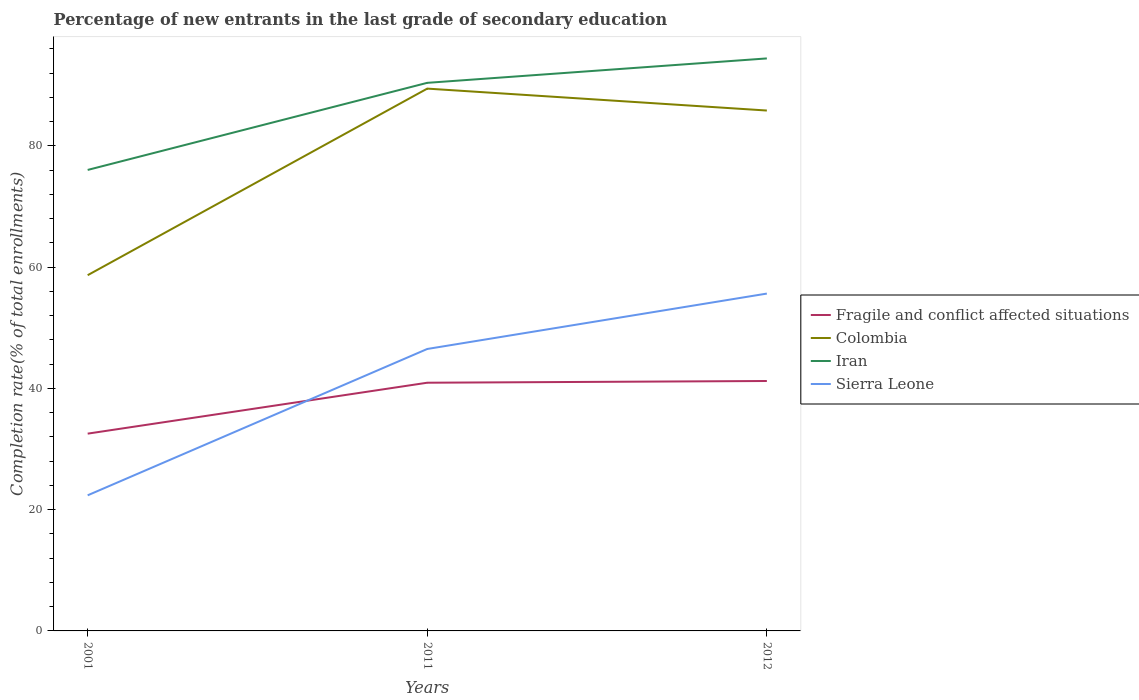Is the number of lines equal to the number of legend labels?
Your answer should be compact. Yes. Across all years, what is the maximum percentage of new entrants in Fragile and conflict affected situations?
Provide a succinct answer. 32.53. What is the total percentage of new entrants in Sierra Leone in the graph?
Provide a succinct answer. -33.27. What is the difference between the highest and the second highest percentage of new entrants in Sierra Leone?
Offer a very short reply. 33.27. What is the difference between the highest and the lowest percentage of new entrants in Colombia?
Keep it short and to the point. 2. Is the percentage of new entrants in Colombia strictly greater than the percentage of new entrants in Fragile and conflict affected situations over the years?
Provide a short and direct response. No. How many lines are there?
Provide a succinct answer. 4. What is the difference between two consecutive major ticks on the Y-axis?
Keep it short and to the point. 20. Are the values on the major ticks of Y-axis written in scientific E-notation?
Provide a succinct answer. No. Where does the legend appear in the graph?
Provide a succinct answer. Center right. What is the title of the graph?
Offer a terse response. Percentage of new entrants in the last grade of secondary education. What is the label or title of the Y-axis?
Provide a short and direct response. Completion rate(% of total enrollments). What is the Completion rate(% of total enrollments) in Fragile and conflict affected situations in 2001?
Keep it short and to the point. 32.53. What is the Completion rate(% of total enrollments) in Colombia in 2001?
Offer a terse response. 58.66. What is the Completion rate(% of total enrollments) in Iran in 2001?
Keep it short and to the point. 76.02. What is the Completion rate(% of total enrollments) of Sierra Leone in 2001?
Give a very brief answer. 22.36. What is the Completion rate(% of total enrollments) in Fragile and conflict affected situations in 2011?
Keep it short and to the point. 40.93. What is the Completion rate(% of total enrollments) in Colombia in 2011?
Offer a terse response. 89.43. What is the Completion rate(% of total enrollments) of Iran in 2011?
Ensure brevity in your answer.  90.38. What is the Completion rate(% of total enrollments) of Sierra Leone in 2011?
Your answer should be very brief. 46.49. What is the Completion rate(% of total enrollments) of Fragile and conflict affected situations in 2012?
Your response must be concise. 41.21. What is the Completion rate(% of total enrollments) in Colombia in 2012?
Give a very brief answer. 85.81. What is the Completion rate(% of total enrollments) of Iran in 2012?
Keep it short and to the point. 94.4. What is the Completion rate(% of total enrollments) in Sierra Leone in 2012?
Offer a very short reply. 55.63. Across all years, what is the maximum Completion rate(% of total enrollments) in Fragile and conflict affected situations?
Keep it short and to the point. 41.21. Across all years, what is the maximum Completion rate(% of total enrollments) of Colombia?
Provide a succinct answer. 89.43. Across all years, what is the maximum Completion rate(% of total enrollments) in Iran?
Provide a succinct answer. 94.4. Across all years, what is the maximum Completion rate(% of total enrollments) in Sierra Leone?
Make the answer very short. 55.63. Across all years, what is the minimum Completion rate(% of total enrollments) in Fragile and conflict affected situations?
Provide a succinct answer. 32.53. Across all years, what is the minimum Completion rate(% of total enrollments) in Colombia?
Offer a very short reply. 58.66. Across all years, what is the minimum Completion rate(% of total enrollments) of Iran?
Provide a succinct answer. 76.02. Across all years, what is the minimum Completion rate(% of total enrollments) in Sierra Leone?
Your response must be concise. 22.36. What is the total Completion rate(% of total enrollments) in Fragile and conflict affected situations in the graph?
Your response must be concise. 114.67. What is the total Completion rate(% of total enrollments) in Colombia in the graph?
Your answer should be compact. 233.9. What is the total Completion rate(% of total enrollments) of Iran in the graph?
Ensure brevity in your answer.  260.8. What is the total Completion rate(% of total enrollments) of Sierra Leone in the graph?
Offer a very short reply. 124.48. What is the difference between the Completion rate(% of total enrollments) of Fragile and conflict affected situations in 2001 and that in 2011?
Keep it short and to the point. -8.4. What is the difference between the Completion rate(% of total enrollments) of Colombia in 2001 and that in 2011?
Your answer should be very brief. -30.77. What is the difference between the Completion rate(% of total enrollments) in Iran in 2001 and that in 2011?
Your answer should be compact. -14.36. What is the difference between the Completion rate(% of total enrollments) in Sierra Leone in 2001 and that in 2011?
Make the answer very short. -24.13. What is the difference between the Completion rate(% of total enrollments) of Fragile and conflict affected situations in 2001 and that in 2012?
Ensure brevity in your answer.  -8.68. What is the difference between the Completion rate(% of total enrollments) of Colombia in 2001 and that in 2012?
Make the answer very short. -27.15. What is the difference between the Completion rate(% of total enrollments) in Iran in 2001 and that in 2012?
Provide a succinct answer. -18.39. What is the difference between the Completion rate(% of total enrollments) in Sierra Leone in 2001 and that in 2012?
Your response must be concise. -33.27. What is the difference between the Completion rate(% of total enrollments) of Fragile and conflict affected situations in 2011 and that in 2012?
Provide a succinct answer. -0.28. What is the difference between the Completion rate(% of total enrollments) in Colombia in 2011 and that in 2012?
Offer a very short reply. 3.61. What is the difference between the Completion rate(% of total enrollments) in Iran in 2011 and that in 2012?
Your answer should be very brief. -4.03. What is the difference between the Completion rate(% of total enrollments) of Sierra Leone in 2011 and that in 2012?
Offer a very short reply. -9.13. What is the difference between the Completion rate(% of total enrollments) of Fragile and conflict affected situations in 2001 and the Completion rate(% of total enrollments) of Colombia in 2011?
Offer a terse response. -56.89. What is the difference between the Completion rate(% of total enrollments) in Fragile and conflict affected situations in 2001 and the Completion rate(% of total enrollments) in Iran in 2011?
Offer a terse response. -57.85. What is the difference between the Completion rate(% of total enrollments) in Fragile and conflict affected situations in 2001 and the Completion rate(% of total enrollments) in Sierra Leone in 2011?
Give a very brief answer. -13.96. What is the difference between the Completion rate(% of total enrollments) of Colombia in 2001 and the Completion rate(% of total enrollments) of Iran in 2011?
Provide a short and direct response. -31.72. What is the difference between the Completion rate(% of total enrollments) in Colombia in 2001 and the Completion rate(% of total enrollments) in Sierra Leone in 2011?
Make the answer very short. 12.17. What is the difference between the Completion rate(% of total enrollments) in Iran in 2001 and the Completion rate(% of total enrollments) in Sierra Leone in 2011?
Ensure brevity in your answer.  29.52. What is the difference between the Completion rate(% of total enrollments) of Fragile and conflict affected situations in 2001 and the Completion rate(% of total enrollments) of Colombia in 2012?
Keep it short and to the point. -53.28. What is the difference between the Completion rate(% of total enrollments) of Fragile and conflict affected situations in 2001 and the Completion rate(% of total enrollments) of Iran in 2012?
Your answer should be compact. -61.87. What is the difference between the Completion rate(% of total enrollments) of Fragile and conflict affected situations in 2001 and the Completion rate(% of total enrollments) of Sierra Leone in 2012?
Offer a terse response. -23.1. What is the difference between the Completion rate(% of total enrollments) of Colombia in 2001 and the Completion rate(% of total enrollments) of Iran in 2012?
Give a very brief answer. -35.75. What is the difference between the Completion rate(% of total enrollments) of Colombia in 2001 and the Completion rate(% of total enrollments) of Sierra Leone in 2012?
Ensure brevity in your answer.  3.03. What is the difference between the Completion rate(% of total enrollments) in Iran in 2001 and the Completion rate(% of total enrollments) in Sierra Leone in 2012?
Provide a succinct answer. 20.39. What is the difference between the Completion rate(% of total enrollments) of Fragile and conflict affected situations in 2011 and the Completion rate(% of total enrollments) of Colombia in 2012?
Your answer should be compact. -44.88. What is the difference between the Completion rate(% of total enrollments) of Fragile and conflict affected situations in 2011 and the Completion rate(% of total enrollments) of Iran in 2012?
Give a very brief answer. -53.48. What is the difference between the Completion rate(% of total enrollments) of Fragile and conflict affected situations in 2011 and the Completion rate(% of total enrollments) of Sierra Leone in 2012?
Provide a succinct answer. -14.7. What is the difference between the Completion rate(% of total enrollments) in Colombia in 2011 and the Completion rate(% of total enrollments) in Iran in 2012?
Your answer should be compact. -4.98. What is the difference between the Completion rate(% of total enrollments) in Colombia in 2011 and the Completion rate(% of total enrollments) in Sierra Leone in 2012?
Offer a terse response. 33.8. What is the difference between the Completion rate(% of total enrollments) of Iran in 2011 and the Completion rate(% of total enrollments) of Sierra Leone in 2012?
Ensure brevity in your answer.  34.75. What is the average Completion rate(% of total enrollments) of Fragile and conflict affected situations per year?
Offer a very short reply. 38.22. What is the average Completion rate(% of total enrollments) in Colombia per year?
Ensure brevity in your answer.  77.97. What is the average Completion rate(% of total enrollments) in Iran per year?
Make the answer very short. 86.93. What is the average Completion rate(% of total enrollments) of Sierra Leone per year?
Provide a succinct answer. 41.49. In the year 2001, what is the difference between the Completion rate(% of total enrollments) in Fragile and conflict affected situations and Completion rate(% of total enrollments) in Colombia?
Keep it short and to the point. -26.13. In the year 2001, what is the difference between the Completion rate(% of total enrollments) in Fragile and conflict affected situations and Completion rate(% of total enrollments) in Iran?
Make the answer very short. -43.48. In the year 2001, what is the difference between the Completion rate(% of total enrollments) in Fragile and conflict affected situations and Completion rate(% of total enrollments) in Sierra Leone?
Keep it short and to the point. 10.17. In the year 2001, what is the difference between the Completion rate(% of total enrollments) in Colombia and Completion rate(% of total enrollments) in Iran?
Your answer should be very brief. -17.36. In the year 2001, what is the difference between the Completion rate(% of total enrollments) of Colombia and Completion rate(% of total enrollments) of Sierra Leone?
Your response must be concise. 36.3. In the year 2001, what is the difference between the Completion rate(% of total enrollments) in Iran and Completion rate(% of total enrollments) in Sierra Leone?
Offer a very short reply. 53.65. In the year 2011, what is the difference between the Completion rate(% of total enrollments) in Fragile and conflict affected situations and Completion rate(% of total enrollments) in Colombia?
Ensure brevity in your answer.  -48.5. In the year 2011, what is the difference between the Completion rate(% of total enrollments) of Fragile and conflict affected situations and Completion rate(% of total enrollments) of Iran?
Make the answer very short. -49.45. In the year 2011, what is the difference between the Completion rate(% of total enrollments) of Fragile and conflict affected situations and Completion rate(% of total enrollments) of Sierra Leone?
Your response must be concise. -5.56. In the year 2011, what is the difference between the Completion rate(% of total enrollments) of Colombia and Completion rate(% of total enrollments) of Iran?
Provide a short and direct response. -0.95. In the year 2011, what is the difference between the Completion rate(% of total enrollments) of Colombia and Completion rate(% of total enrollments) of Sierra Leone?
Your response must be concise. 42.93. In the year 2011, what is the difference between the Completion rate(% of total enrollments) in Iran and Completion rate(% of total enrollments) in Sierra Leone?
Give a very brief answer. 43.89. In the year 2012, what is the difference between the Completion rate(% of total enrollments) in Fragile and conflict affected situations and Completion rate(% of total enrollments) in Colombia?
Provide a succinct answer. -44.6. In the year 2012, what is the difference between the Completion rate(% of total enrollments) in Fragile and conflict affected situations and Completion rate(% of total enrollments) in Iran?
Provide a short and direct response. -53.19. In the year 2012, what is the difference between the Completion rate(% of total enrollments) in Fragile and conflict affected situations and Completion rate(% of total enrollments) in Sierra Leone?
Provide a short and direct response. -14.41. In the year 2012, what is the difference between the Completion rate(% of total enrollments) of Colombia and Completion rate(% of total enrollments) of Iran?
Provide a short and direct response. -8.59. In the year 2012, what is the difference between the Completion rate(% of total enrollments) in Colombia and Completion rate(% of total enrollments) in Sierra Leone?
Offer a very short reply. 30.19. In the year 2012, what is the difference between the Completion rate(% of total enrollments) of Iran and Completion rate(% of total enrollments) of Sierra Leone?
Provide a short and direct response. 38.78. What is the ratio of the Completion rate(% of total enrollments) of Fragile and conflict affected situations in 2001 to that in 2011?
Your answer should be very brief. 0.79. What is the ratio of the Completion rate(% of total enrollments) in Colombia in 2001 to that in 2011?
Offer a terse response. 0.66. What is the ratio of the Completion rate(% of total enrollments) of Iran in 2001 to that in 2011?
Your answer should be very brief. 0.84. What is the ratio of the Completion rate(% of total enrollments) in Sierra Leone in 2001 to that in 2011?
Make the answer very short. 0.48. What is the ratio of the Completion rate(% of total enrollments) of Fragile and conflict affected situations in 2001 to that in 2012?
Provide a short and direct response. 0.79. What is the ratio of the Completion rate(% of total enrollments) of Colombia in 2001 to that in 2012?
Your answer should be compact. 0.68. What is the ratio of the Completion rate(% of total enrollments) in Iran in 2001 to that in 2012?
Make the answer very short. 0.81. What is the ratio of the Completion rate(% of total enrollments) of Sierra Leone in 2001 to that in 2012?
Ensure brevity in your answer.  0.4. What is the ratio of the Completion rate(% of total enrollments) in Colombia in 2011 to that in 2012?
Your answer should be compact. 1.04. What is the ratio of the Completion rate(% of total enrollments) of Iran in 2011 to that in 2012?
Your response must be concise. 0.96. What is the ratio of the Completion rate(% of total enrollments) of Sierra Leone in 2011 to that in 2012?
Your response must be concise. 0.84. What is the difference between the highest and the second highest Completion rate(% of total enrollments) of Fragile and conflict affected situations?
Your answer should be very brief. 0.28. What is the difference between the highest and the second highest Completion rate(% of total enrollments) in Colombia?
Your answer should be compact. 3.61. What is the difference between the highest and the second highest Completion rate(% of total enrollments) in Iran?
Provide a succinct answer. 4.03. What is the difference between the highest and the second highest Completion rate(% of total enrollments) of Sierra Leone?
Your answer should be very brief. 9.13. What is the difference between the highest and the lowest Completion rate(% of total enrollments) of Fragile and conflict affected situations?
Offer a very short reply. 8.68. What is the difference between the highest and the lowest Completion rate(% of total enrollments) of Colombia?
Make the answer very short. 30.77. What is the difference between the highest and the lowest Completion rate(% of total enrollments) in Iran?
Make the answer very short. 18.39. What is the difference between the highest and the lowest Completion rate(% of total enrollments) in Sierra Leone?
Ensure brevity in your answer.  33.27. 